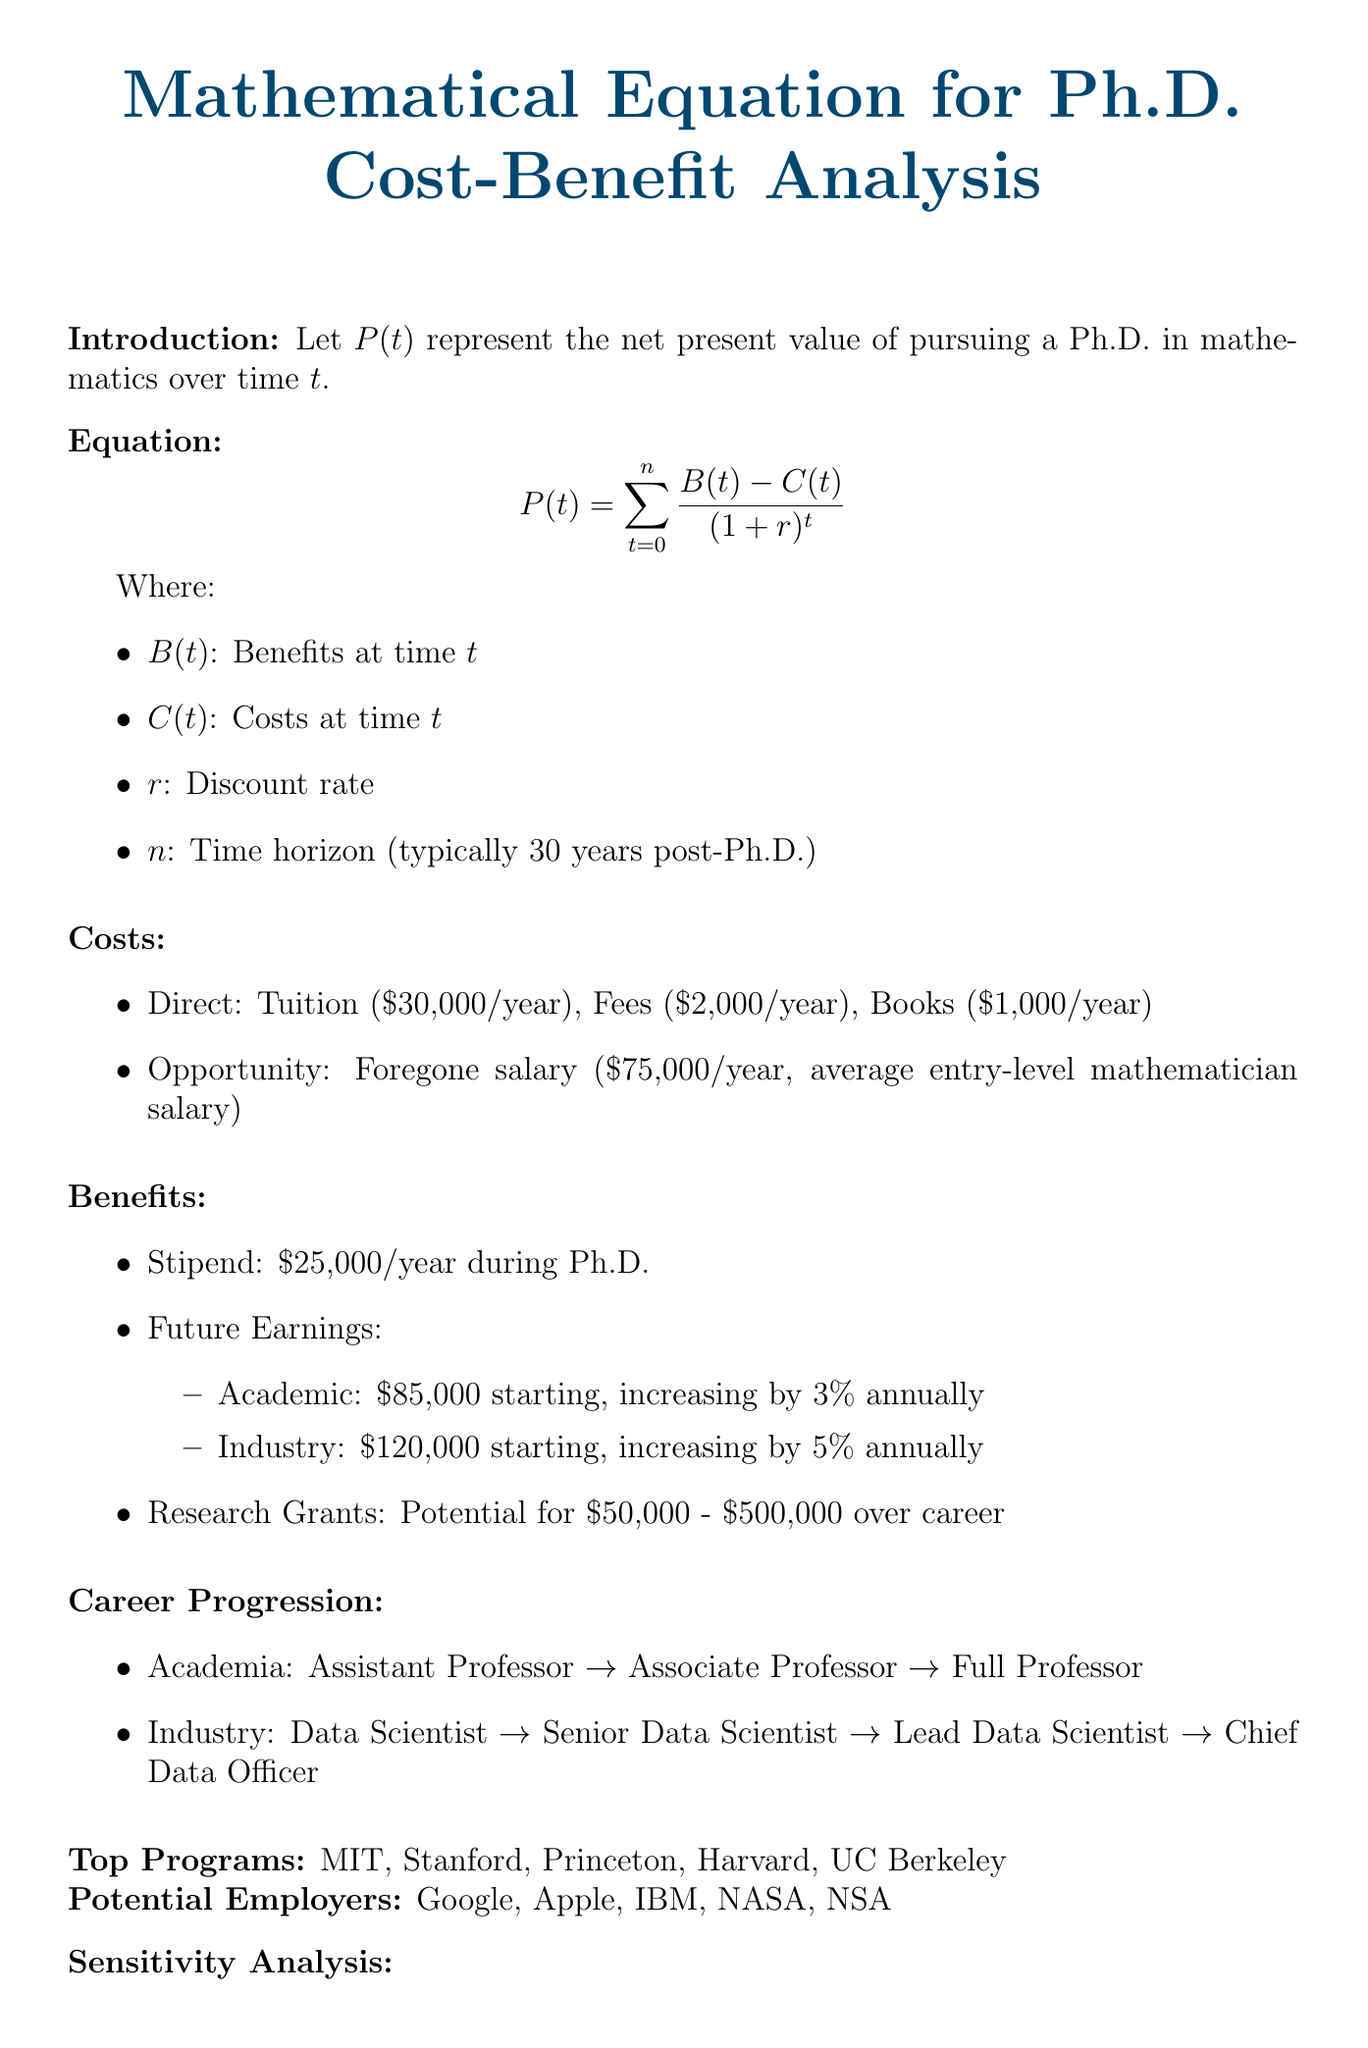What does P(t) represent? P(t) represents the net present value of pursuing a Ph.D. in mathematics over time t.
Answer: net present value What is the average entry-level mathematician salary? The document states that the average entry-level mathematician salary is the foregone salary in the opportunity costs section.
Answer: $75,000 per year What is the starting salary in academia after obtaining a Ph.D.? The document provides information about future earnings in academia, specifically indicating the initial salary.
Answer: $85,000 What is the discount rate denoted as in the equation? The document declares 'r' as the discount rate in the equation section.
Answer: r What are the top programs mentioned in the document? The document lists prestigious institutions that represent the top programs for pursuing a Ph.D. in mathematics.
Answer: MIT, Stanford, Princeton, Harvard, UC Berkeley What analysis method is used for the sensitivity analysis? The method used for the sensitivity analysis is specified in the document's sensitivity analysis section.
Answer: Monte Carlo simulation What is the potential range of research grants over a career? The document indicates the expected financial benefits from research grants.
Answer: $50,000 - $500,000 What is the phrase used to qualify the decision to pursue a Ph.D.? The conclusion section illustrates a condition for a positive consideration of the Ph.D. pursuit.
Answer: P(t) > 0 